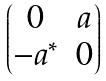Convert formula to latex. <formula><loc_0><loc_0><loc_500><loc_500>\begin{pmatrix} 0 & a \\ - a ^ { * } & 0 \end{pmatrix}</formula> 